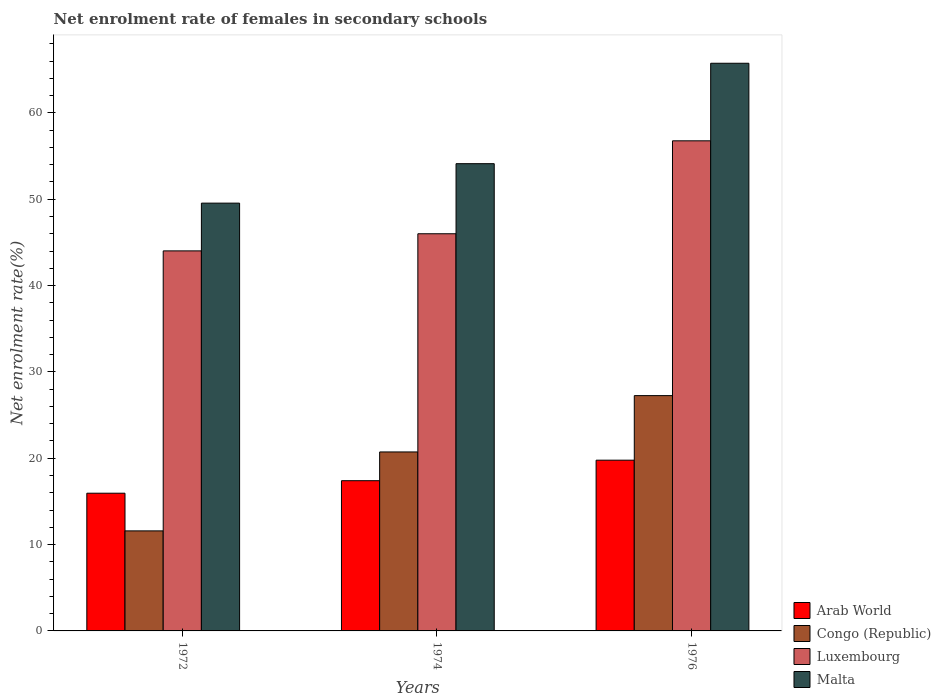Are the number of bars per tick equal to the number of legend labels?
Your answer should be very brief. Yes. How many bars are there on the 2nd tick from the left?
Ensure brevity in your answer.  4. What is the label of the 3rd group of bars from the left?
Provide a succinct answer. 1976. In how many cases, is the number of bars for a given year not equal to the number of legend labels?
Ensure brevity in your answer.  0. What is the net enrolment rate of females in secondary schools in Arab World in 1974?
Keep it short and to the point. 17.4. Across all years, what is the maximum net enrolment rate of females in secondary schools in Arab World?
Provide a short and direct response. 19.78. Across all years, what is the minimum net enrolment rate of females in secondary schools in Malta?
Keep it short and to the point. 49.55. In which year was the net enrolment rate of females in secondary schools in Arab World maximum?
Provide a succinct answer. 1976. In which year was the net enrolment rate of females in secondary schools in Malta minimum?
Your answer should be very brief. 1972. What is the total net enrolment rate of females in secondary schools in Congo (Republic) in the graph?
Provide a short and direct response. 59.57. What is the difference between the net enrolment rate of females in secondary schools in Luxembourg in 1972 and that in 1974?
Make the answer very short. -1.98. What is the difference between the net enrolment rate of females in secondary schools in Malta in 1974 and the net enrolment rate of females in secondary schools in Arab World in 1972?
Provide a succinct answer. 38.17. What is the average net enrolment rate of females in secondary schools in Luxembourg per year?
Your response must be concise. 48.93. In the year 1972, what is the difference between the net enrolment rate of females in secondary schools in Luxembourg and net enrolment rate of females in secondary schools in Congo (Republic)?
Your answer should be compact. 32.43. What is the ratio of the net enrolment rate of females in secondary schools in Arab World in 1974 to that in 1976?
Provide a succinct answer. 0.88. Is the net enrolment rate of females in secondary schools in Luxembourg in 1974 less than that in 1976?
Provide a succinct answer. Yes. Is the difference between the net enrolment rate of females in secondary schools in Luxembourg in 1972 and 1974 greater than the difference between the net enrolment rate of females in secondary schools in Congo (Republic) in 1972 and 1974?
Give a very brief answer. Yes. What is the difference between the highest and the second highest net enrolment rate of females in secondary schools in Luxembourg?
Provide a short and direct response. 10.76. What is the difference between the highest and the lowest net enrolment rate of females in secondary schools in Luxembourg?
Give a very brief answer. 12.75. In how many years, is the net enrolment rate of females in secondary schools in Malta greater than the average net enrolment rate of females in secondary schools in Malta taken over all years?
Make the answer very short. 1. Is the sum of the net enrolment rate of females in secondary schools in Arab World in 1972 and 1974 greater than the maximum net enrolment rate of females in secondary schools in Luxembourg across all years?
Provide a succinct answer. No. What does the 3rd bar from the left in 1972 represents?
Make the answer very short. Luxembourg. What does the 3rd bar from the right in 1974 represents?
Give a very brief answer. Congo (Republic). Is it the case that in every year, the sum of the net enrolment rate of females in secondary schools in Arab World and net enrolment rate of females in secondary schools in Congo (Republic) is greater than the net enrolment rate of females in secondary schools in Luxembourg?
Make the answer very short. No. How many bars are there?
Offer a very short reply. 12. Are all the bars in the graph horizontal?
Provide a succinct answer. No. How many years are there in the graph?
Your answer should be very brief. 3. Are the values on the major ticks of Y-axis written in scientific E-notation?
Provide a short and direct response. No. Does the graph contain any zero values?
Provide a succinct answer. No. Does the graph contain grids?
Offer a terse response. No. How are the legend labels stacked?
Ensure brevity in your answer.  Vertical. What is the title of the graph?
Give a very brief answer. Net enrolment rate of females in secondary schools. What is the label or title of the X-axis?
Offer a terse response. Years. What is the label or title of the Y-axis?
Your response must be concise. Net enrolment rate(%). What is the Net enrolment rate(%) of Arab World in 1972?
Provide a succinct answer. 15.95. What is the Net enrolment rate(%) in Congo (Republic) in 1972?
Provide a short and direct response. 11.59. What is the Net enrolment rate(%) in Luxembourg in 1972?
Keep it short and to the point. 44.02. What is the Net enrolment rate(%) of Malta in 1972?
Your response must be concise. 49.55. What is the Net enrolment rate(%) of Arab World in 1974?
Your answer should be compact. 17.4. What is the Net enrolment rate(%) of Congo (Republic) in 1974?
Offer a very short reply. 20.73. What is the Net enrolment rate(%) of Luxembourg in 1974?
Provide a short and direct response. 46. What is the Net enrolment rate(%) of Malta in 1974?
Provide a succinct answer. 54.12. What is the Net enrolment rate(%) of Arab World in 1976?
Offer a terse response. 19.78. What is the Net enrolment rate(%) in Congo (Republic) in 1976?
Offer a terse response. 27.25. What is the Net enrolment rate(%) in Luxembourg in 1976?
Your answer should be very brief. 56.76. What is the Net enrolment rate(%) in Malta in 1976?
Keep it short and to the point. 65.75. Across all years, what is the maximum Net enrolment rate(%) of Arab World?
Keep it short and to the point. 19.78. Across all years, what is the maximum Net enrolment rate(%) of Congo (Republic)?
Ensure brevity in your answer.  27.25. Across all years, what is the maximum Net enrolment rate(%) of Luxembourg?
Your response must be concise. 56.76. Across all years, what is the maximum Net enrolment rate(%) in Malta?
Your response must be concise. 65.75. Across all years, what is the minimum Net enrolment rate(%) in Arab World?
Give a very brief answer. 15.95. Across all years, what is the minimum Net enrolment rate(%) of Congo (Republic)?
Your response must be concise. 11.59. Across all years, what is the minimum Net enrolment rate(%) in Luxembourg?
Your answer should be very brief. 44.02. Across all years, what is the minimum Net enrolment rate(%) in Malta?
Your answer should be very brief. 49.55. What is the total Net enrolment rate(%) in Arab World in the graph?
Offer a terse response. 53.12. What is the total Net enrolment rate(%) in Congo (Republic) in the graph?
Offer a very short reply. 59.57. What is the total Net enrolment rate(%) of Luxembourg in the graph?
Offer a terse response. 146.78. What is the total Net enrolment rate(%) in Malta in the graph?
Make the answer very short. 169.41. What is the difference between the Net enrolment rate(%) of Arab World in 1972 and that in 1974?
Give a very brief answer. -1.45. What is the difference between the Net enrolment rate(%) of Congo (Republic) in 1972 and that in 1974?
Provide a succinct answer. -9.14. What is the difference between the Net enrolment rate(%) of Luxembourg in 1972 and that in 1974?
Give a very brief answer. -1.98. What is the difference between the Net enrolment rate(%) of Malta in 1972 and that in 1974?
Keep it short and to the point. -4.57. What is the difference between the Net enrolment rate(%) of Arab World in 1972 and that in 1976?
Your response must be concise. -3.83. What is the difference between the Net enrolment rate(%) in Congo (Republic) in 1972 and that in 1976?
Offer a terse response. -15.67. What is the difference between the Net enrolment rate(%) in Luxembourg in 1972 and that in 1976?
Offer a very short reply. -12.75. What is the difference between the Net enrolment rate(%) of Malta in 1972 and that in 1976?
Your answer should be compact. -16.2. What is the difference between the Net enrolment rate(%) of Arab World in 1974 and that in 1976?
Give a very brief answer. -2.38. What is the difference between the Net enrolment rate(%) in Congo (Republic) in 1974 and that in 1976?
Provide a succinct answer. -6.52. What is the difference between the Net enrolment rate(%) of Luxembourg in 1974 and that in 1976?
Give a very brief answer. -10.77. What is the difference between the Net enrolment rate(%) in Malta in 1974 and that in 1976?
Offer a very short reply. -11.63. What is the difference between the Net enrolment rate(%) in Arab World in 1972 and the Net enrolment rate(%) in Congo (Republic) in 1974?
Your answer should be compact. -4.78. What is the difference between the Net enrolment rate(%) in Arab World in 1972 and the Net enrolment rate(%) in Luxembourg in 1974?
Your answer should be very brief. -30.05. What is the difference between the Net enrolment rate(%) in Arab World in 1972 and the Net enrolment rate(%) in Malta in 1974?
Your answer should be compact. -38.17. What is the difference between the Net enrolment rate(%) in Congo (Republic) in 1972 and the Net enrolment rate(%) in Luxembourg in 1974?
Make the answer very short. -34.41. What is the difference between the Net enrolment rate(%) of Congo (Republic) in 1972 and the Net enrolment rate(%) of Malta in 1974?
Your answer should be compact. -42.53. What is the difference between the Net enrolment rate(%) of Luxembourg in 1972 and the Net enrolment rate(%) of Malta in 1974?
Offer a very short reply. -10.1. What is the difference between the Net enrolment rate(%) of Arab World in 1972 and the Net enrolment rate(%) of Congo (Republic) in 1976?
Your response must be concise. -11.3. What is the difference between the Net enrolment rate(%) of Arab World in 1972 and the Net enrolment rate(%) of Luxembourg in 1976?
Ensure brevity in your answer.  -40.81. What is the difference between the Net enrolment rate(%) of Arab World in 1972 and the Net enrolment rate(%) of Malta in 1976?
Provide a short and direct response. -49.8. What is the difference between the Net enrolment rate(%) in Congo (Republic) in 1972 and the Net enrolment rate(%) in Luxembourg in 1976?
Provide a succinct answer. -45.18. What is the difference between the Net enrolment rate(%) of Congo (Republic) in 1972 and the Net enrolment rate(%) of Malta in 1976?
Ensure brevity in your answer.  -54.16. What is the difference between the Net enrolment rate(%) of Luxembourg in 1972 and the Net enrolment rate(%) of Malta in 1976?
Make the answer very short. -21.73. What is the difference between the Net enrolment rate(%) in Arab World in 1974 and the Net enrolment rate(%) in Congo (Republic) in 1976?
Your answer should be very brief. -9.85. What is the difference between the Net enrolment rate(%) of Arab World in 1974 and the Net enrolment rate(%) of Luxembourg in 1976?
Make the answer very short. -39.36. What is the difference between the Net enrolment rate(%) of Arab World in 1974 and the Net enrolment rate(%) of Malta in 1976?
Keep it short and to the point. -48.35. What is the difference between the Net enrolment rate(%) of Congo (Republic) in 1974 and the Net enrolment rate(%) of Luxembourg in 1976?
Your answer should be compact. -36.03. What is the difference between the Net enrolment rate(%) of Congo (Republic) in 1974 and the Net enrolment rate(%) of Malta in 1976?
Your answer should be very brief. -45.02. What is the difference between the Net enrolment rate(%) of Luxembourg in 1974 and the Net enrolment rate(%) of Malta in 1976?
Give a very brief answer. -19.75. What is the average Net enrolment rate(%) in Arab World per year?
Keep it short and to the point. 17.71. What is the average Net enrolment rate(%) in Congo (Republic) per year?
Your response must be concise. 19.86. What is the average Net enrolment rate(%) of Luxembourg per year?
Offer a very short reply. 48.93. What is the average Net enrolment rate(%) in Malta per year?
Ensure brevity in your answer.  56.47. In the year 1972, what is the difference between the Net enrolment rate(%) of Arab World and Net enrolment rate(%) of Congo (Republic)?
Offer a terse response. 4.36. In the year 1972, what is the difference between the Net enrolment rate(%) of Arab World and Net enrolment rate(%) of Luxembourg?
Make the answer very short. -28.07. In the year 1972, what is the difference between the Net enrolment rate(%) in Arab World and Net enrolment rate(%) in Malta?
Your answer should be very brief. -33.6. In the year 1972, what is the difference between the Net enrolment rate(%) in Congo (Republic) and Net enrolment rate(%) in Luxembourg?
Offer a terse response. -32.43. In the year 1972, what is the difference between the Net enrolment rate(%) in Congo (Republic) and Net enrolment rate(%) in Malta?
Keep it short and to the point. -37.96. In the year 1972, what is the difference between the Net enrolment rate(%) in Luxembourg and Net enrolment rate(%) in Malta?
Offer a very short reply. -5.53. In the year 1974, what is the difference between the Net enrolment rate(%) of Arab World and Net enrolment rate(%) of Congo (Republic)?
Ensure brevity in your answer.  -3.33. In the year 1974, what is the difference between the Net enrolment rate(%) in Arab World and Net enrolment rate(%) in Luxembourg?
Your response must be concise. -28.6. In the year 1974, what is the difference between the Net enrolment rate(%) in Arab World and Net enrolment rate(%) in Malta?
Your response must be concise. -36.72. In the year 1974, what is the difference between the Net enrolment rate(%) of Congo (Republic) and Net enrolment rate(%) of Luxembourg?
Keep it short and to the point. -25.27. In the year 1974, what is the difference between the Net enrolment rate(%) of Congo (Republic) and Net enrolment rate(%) of Malta?
Offer a very short reply. -33.39. In the year 1974, what is the difference between the Net enrolment rate(%) of Luxembourg and Net enrolment rate(%) of Malta?
Make the answer very short. -8.12. In the year 1976, what is the difference between the Net enrolment rate(%) of Arab World and Net enrolment rate(%) of Congo (Republic)?
Offer a very short reply. -7.48. In the year 1976, what is the difference between the Net enrolment rate(%) in Arab World and Net enrolment rate(%) in Luxembourg?
Your response must be concise. -36.99. In the year 1976, what is the difference between the Net enrolment rate(%) in Arab World and Net enrolment rate(%) in Malta?
Offer a terse response. -45.97. In the year 1976, what is the difference between the Net enrolment rate(%) in Congo (Republic) and Net enrolment rate(%) in Luxembourg?
Your response must be concise. -29.51. In the year 1976, what is the difference between the Net enrolment rate(%) of Congo (Republic) and Net enrolment rate(%) of Malta?
Your answer should be very brief. -38.49. In the year 1976, what is the difference between the Net enrolment rate(%) in Luxembourg and Net enrolment rate(%) in Malta?
Your response must be concise. -8.98. What is the ratio of the Net enrolment rate(%) in Arab World in 1972 to that in 1974?
Provide a short and direct response. 0.92. What is the ratio of the Net enrolment rate(%) in Congo (Republic) in 1972 to that in 1974?
Make the answer very short. 0.56. What is the ratio of the Net enrolment rate(%) of Luxembourg in 1972 to that in 1974?
Provide a succinct answer. 0.96. What is the ratio of the Net enrolment rate(%) of Malta in 1972 to that in 1974?
Offer a very short reply. 0.92. What is the ratio of the Net enrolment rate(%) of Arab World in 1972 to that in 1976?
Your answer should be very brief. 0.81. What is the ratio of the Net enrolment rate(%) of Congo (Republic) in 1972 to that in 1976?
Make the answer very short. 0.43. What is the ratio of the Net enrolment rate(%) of Luxembourg in 1972 to that in 1976?
Keep it short and to the point. 0.78. What is the ratio of the Net enrolment rate(%) in Malta in 1972 to that in 1976?
Your response must be concise. 0.75. What is the ratio of the Net enrolment rate(%) of Arab World in 1974 to that in 1976?
Provide a short and direct response. 0.88. What is the ratio of the Net enrolment rate(%) in Congo (Republic) in 1974 to that in 1976?
Your response must be concise. 0.76. What is the ratio of the Net enrolment rate(%) of Luxembourg in 1974 to that in 1976?
Your response must be concise. 0.81. What is the ratio of the Net enrolment rate(%) in Malta in 1974 to that in 1976?
Keep it short and to the point. 0.82. What is the difference between the highest and the second highest Net enrolment rate(%) in Arab World?
Offer a very short reply. 2.38. What is the difference between the highest and the second highest Net enrolment rate(%) of Congo (Republic)?
Offer a terse response. 6.52. What is the difference between the highest and the second highest Net enrolment rate(%) in Luxembourg?
Your answer should be compact. 10.77. What is the difference between the highest and the second highest Net enrolment rate(%) of Malta?
Offer a terse response. 11.63. What is the difference between the highest and the lowest Net enrolment rate(%) in Arab World?
Offer a terse response. 3.83. What is the difference between the highest and the lowest Net enrolment rate(%) of Congo (Republic)?
Your response must be concise. 15.67. What is the difference between the highest and the lowest Net enrolment rate(%) in Luxembourg?
Offer a very short reply. 12.75. 